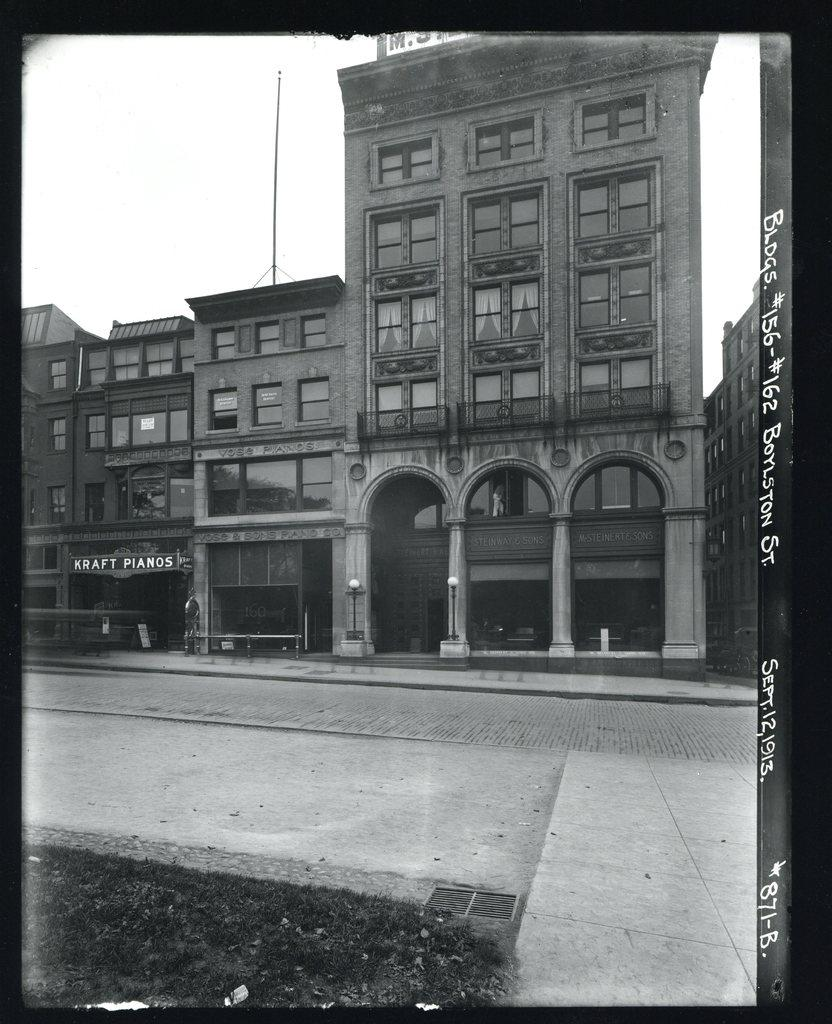What type of structures are present in the image? There are buildings in the image. What is visible at the top of the image? The sky is visible at the top of the image. How would you describe the sky in the image? The sky appears to be clear in the image. How many houses can be seen at the edge of the image? There is no mention of houses in the image, and the term "edge" is not relevant to the provided facts. 